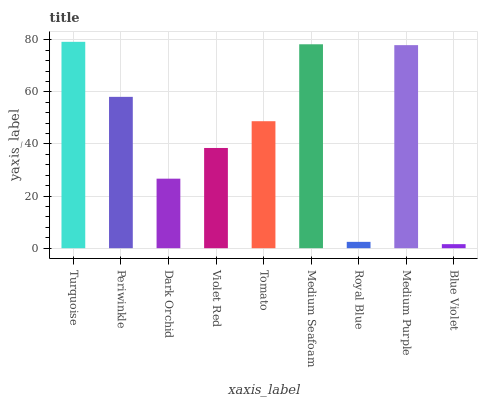Is Blue Violet the minimum?
Answer yes or no. Yes. Is Turquoise the maximum?
Answer yes or no. Yes. Is Periwinkle the minimum?
Answer yes or no. No. Is Periwinkle the maximum?
Answer yes or no. No. Is Turquoise greater than Periwinkle?
Answer yes or no. Yes. Is Periwinkle less than Turquoise?
Answer yes or no. Yes. Is Periwinkle greater than Turquoise?
Answer yes or no. No. Is Turquoise less than Periwinkle?
Answer yes or no. No. Is Tomato the high median?
Answer yes or no. Yes. Is Tomato the low median?
Answer yes or no. Yes. Is Periwinkle the high median?
Answer yes or no. No. Is Royal Blue the low median?
Answer yes or no. No. 